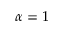<formula> <loc_0><loc_0><loc_500><loc_500>\alpha = 1</formula> 